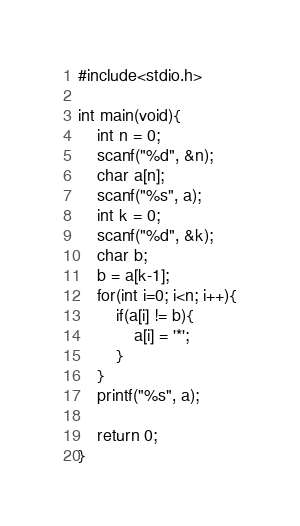<code> <loc_0><loc_0><loc_500><loc_500><_C_>#include<stdio.h>

int main(void){
    int n = 0;
    scanf("%d", &n);
    char a[n];
    scanf("%s", a);
    int k = 0;
    scanf("%d", &k);
    char b;
    b = a[k-1];
    for(int i=0; i<n; i++){
        if(a[i] != b){
            a[i] = '*';
        }
    }
    printf("%s", a);

    return 0;
}</code> 